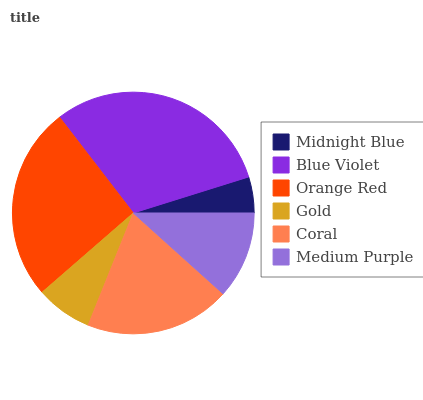Is Midnight Blue the minimum?
Answer yes or no. Yes. Is Blue Violet the maximum?
Answer yes or no. Yes. Is Orange Red the minimum?
Answer yes or no. No. Is Orange Red the maximum?
Answer yes or no. No. Is Blue Violet greater than Orange Red?
Answer yes or no. Yes. Is Orange Red less than Blue Violet?
Answer yes or no. Yes. Is Orange Red greater than Blue Violet?
Answer yes or no. No. Is Blue Violet less than Orange Red?
Answer yes or no. No. Is Coral the high median?
Answer yes or no. Yes. Is Medium Purple the low median?
Answer yes or no. Yes. Is Medium Purple the high median?
Answer yes or no. No. Is Gold the low median?
Answer yes or no. No. 